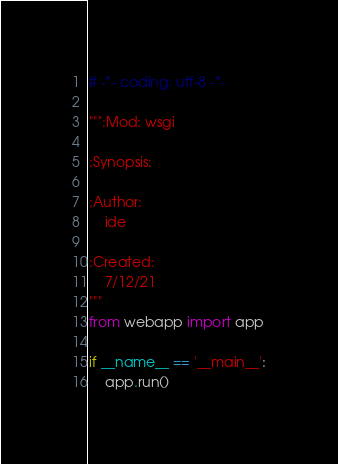Convert code to text. <code><loc_0><loc_0><loc_500><loc_500><_Python_># -*- coding: utf-8 -*-

""":Mod: wsgi

:Synopsis:

:Author:
    ide

:Created:
    7/12/21
"""
from webapp import app

if __name__ == '__main__':
    app.run()
</code> 